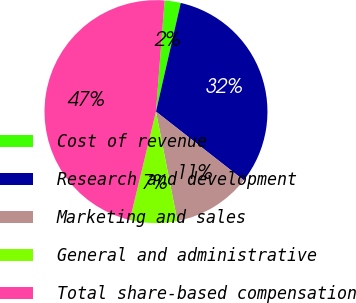<chart> <loc_0><loc_0><loc_500><loc_500><pie_chart><fcel>Cost of revenue<fcel>Research and development<fcel>Marketing and sales<fcel>General and administrative<fcel>Total share-based compensation<nl><fcel>2.33%<fcel>32.0%<fcel>11.36%<fcel>6.84%<fcel>47.47%<nl></chart> 